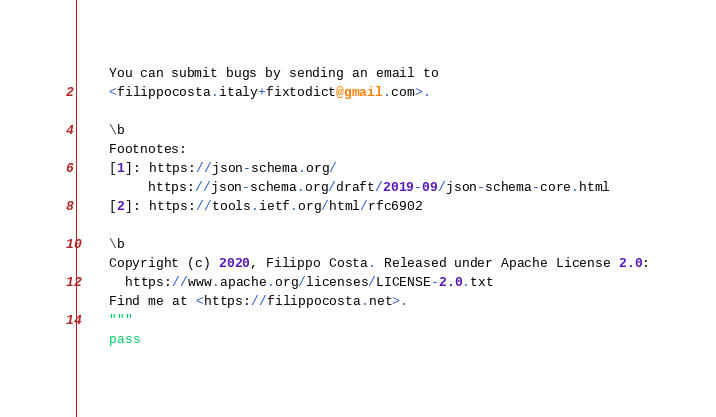<code> <loc_0><loc_0><loc_500><loc_500><_Python_>    You can submit bugs by sending an email to
    <filippocosta.italy+fixtodict@gmail.com>.

    \b
    Footnotes:
    [1]: https://json-schema.org/
         https://json-schema.org/draft/2019-09/json-schema-core.html
    [2]: https://tools.ietf.org/html/rfc6902

    \b
    Copyright (c) 2020, Filippo Costa. Released under Apache License 2.0:
      https://www.apache.org/licenses/LICENSE-2.0.txt
    Find me at <https://filippocosta.net>.
    """
    pass
</code> 